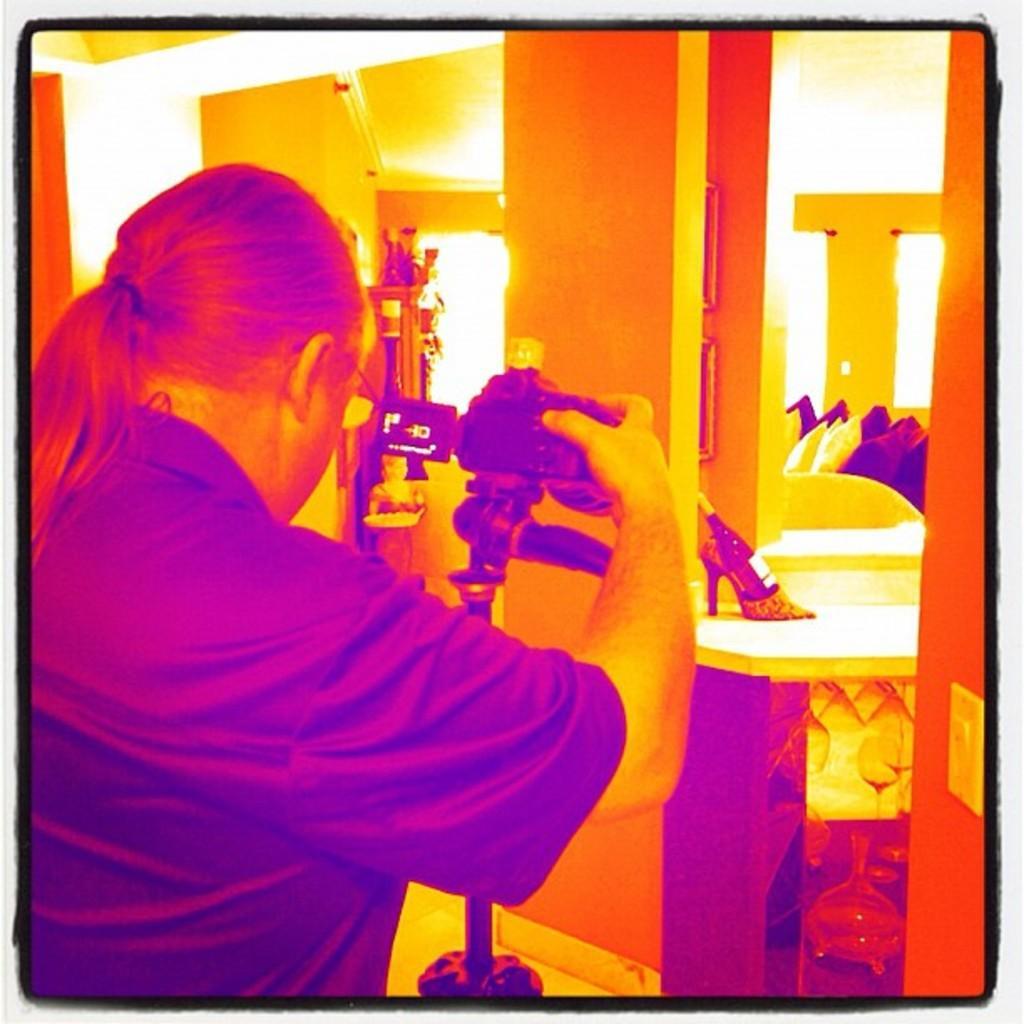How would you summarize this image in a sentence or two? This is a photo and here we can see a person holding a camera stand and in the background, there are some objects and we can see cushions and there is a sandal on the stand. 